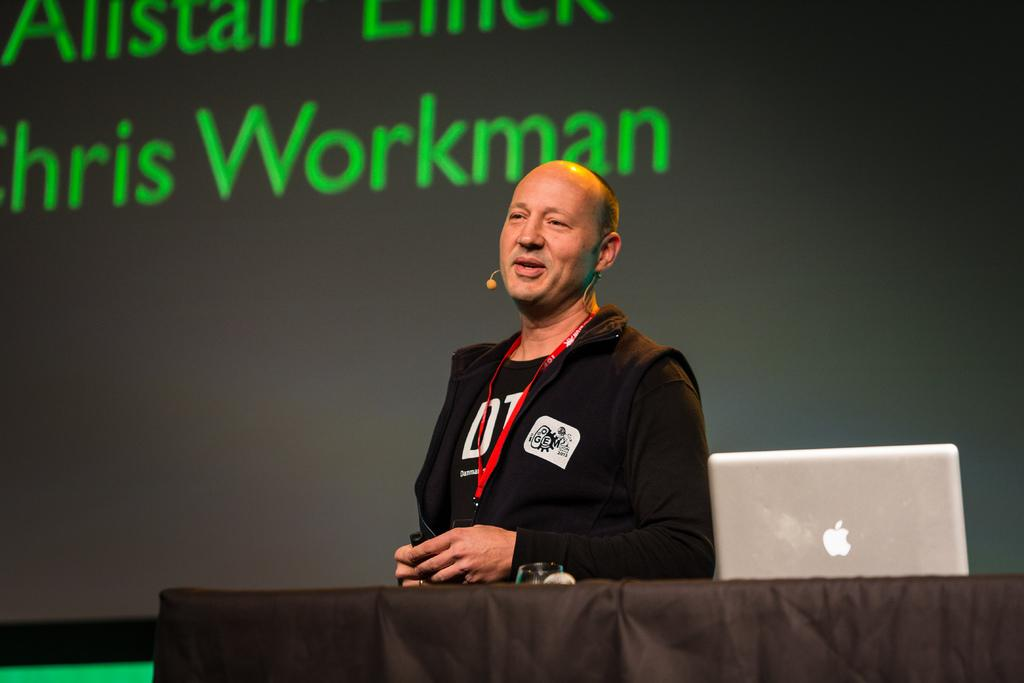<image>
Render a clear and concise summary of the photo. a man talking with the name workman on an ad behind 